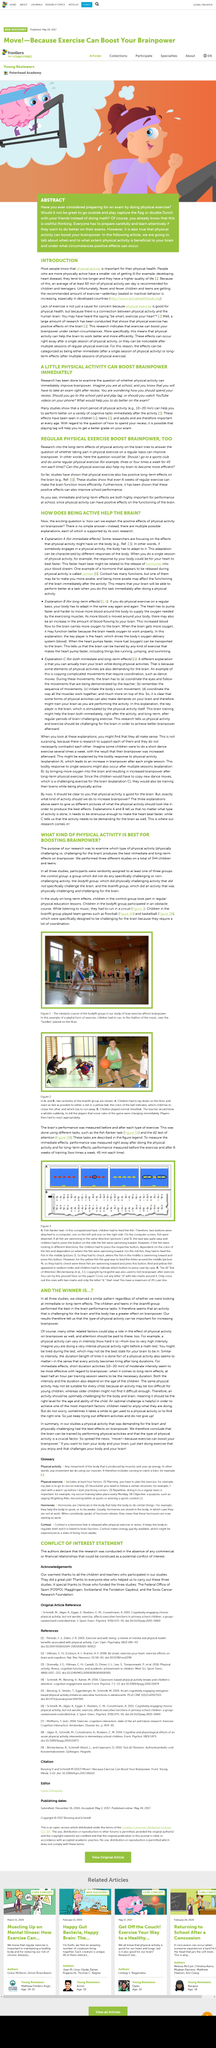List a handful of essential elements in this visual. The article defines short duration activities as being a minimum of 10 minutes. In the study, the participants were divided into three groups: the control group, the bodyfit group, and the brainfit group. I participate in the fish flanker task, which is a computerized task requiring me to feed fish based on specific instructions. Two buttons are attached to a computer, one on the left and one on the right, which I must press according to the directions in order to successfully feed the fish. The two exercises or tasks used to measure brain performance are the Fish flanker task in figure 3A and the d2 test of attention in figure 3B. The participants in the BodyFit group or the BrainFit group who were assigned to exercise while listening to music performed their exercise routines in accordance with the rhythm of the music, while those in the BodyFit group exclusively followed the beat of the music played during their exercise sessions. 